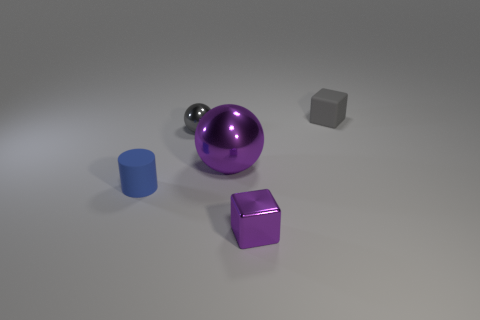Add 3 gray metal objects. How many objects exist? 8 Subtract all spheres. How many objects are left? 3 Add 5 tiny gray rubber things. How many tiny gray rubber things exist? 6 Subtract 0 yellow balls. How many objects are left? 5 Subtract all metal blocks. Subtract all small gray things. How many objects are left? 2 Add 3 matte cubes. How many matte cubes are left? 4 